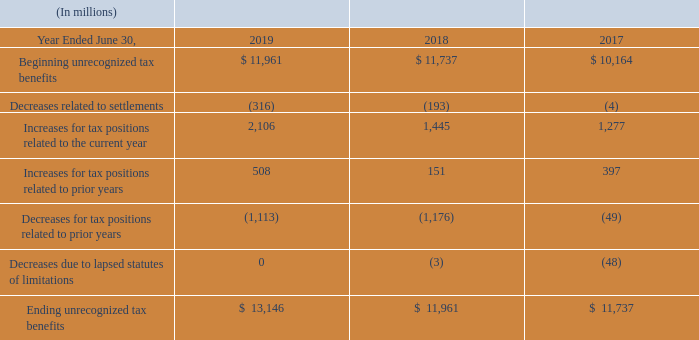Uncertain Tax Positions
As of June 30, 2019, 2018, and 2017, we had accrued interest expense related to uncertain tax positions of $3.4 billion, $3.0 billion, and $2.3 billion, respectively, net of income tax benefits. The provision for (benefit from) income taxes for fiscal years 2019, 2018, and 2017 included interest expense related to uncertain tax positions of $515 million, $688 million, and $399 million, respectively, net of income tax benefits.
The aggregate changes in the gross unrecognized tax benefits related to uncertain tax positions were as follows:
We settled a portion of the Internal Revenue Service (“IRS”) audit for tax years 2004 to 2006 in fiscal year 2011. In February 2012, the IRS withdrew its 2011 Revenue Agents Report related to unresolved issues for tax years 2004 to 2006 and reopened the audit phase of the examination. We also settled a portion of the IRS audit for tax years 2007 to 2009 in fiscal year 2016, and a portion of the IRS audit for tax years 2010 to 2013 in fiscal year 2018. We remain under audit for tax years 2004 to 2013. We expect the IRS to begin an examination of tax years 2014 to 2017 within the next 12 months.
As of June 30, 2019, the primary unresolved issues for the IRS audits relate to transfer pricing, which could have a material impact on our consolidated financial statements when the matters are resolved. We believe our allowances for income tax contingencies are adequate. We have not received a proposed assessment for the unresolved issues and do not expect a final resolution of these issues in the next 12 months. Based on the information currently available, we do not anticipate a significant increase or decrease to our tax contingencies for these issues within the next 12 months.
We are subject to income tax in many jurisdictions outside the U.S. Our operations in certain jurisdictions remain subject to examination for tax years 1996 to 2018, some of which are currently under audit by local tax authorities. The resolution of each of these audits is not expected to be material to our consolidated financial statements.
When does the company expect the IRS to begin an examination of tax years 2014 to 2017? We expect the irs to begin an examination of tax years 2014 to 2017 within the next 12 months. When did the IRS withdraw the 2011 Revenue Agents Report? In february 2012, the irs withdrew its 2011 revenue agents report related to unresolved issues for tax years 2004 to 2006 and reopened the audit phase of the examination. How much was the accrued interest expense related to uncertain tax positions as of June 30, 2019? As of june 30, 2019, 2018, and 2017, we had accrued interest expense related to uncertain tax positions of $3.4 billion, $3.0 billion, and $2.3 billion, respectively, net of income tax benefits. How many years between 2017 and 2019 had ending unrecognized tax benefits of over $12,000 million? 13,146
Answer: 1. How many years between 2017 and 2019 had Increases for tax positions related to prior years that were greater than 100million? 508##151##397
Answer: 3. Which of the 3 years had the highest ending unrecognized tax benefits? 13,146 > 11,961 > 11,737
Answer: 2019. 